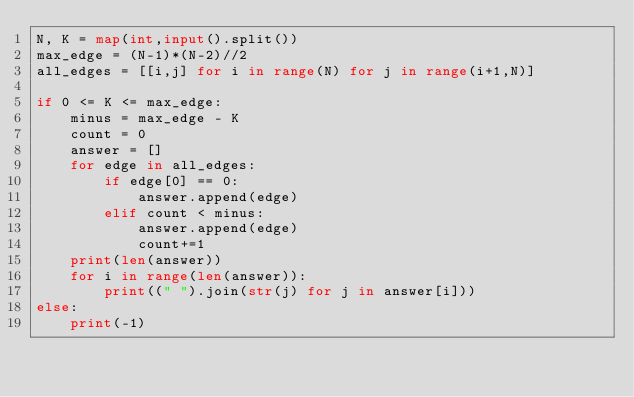<code> <loc_0><loc_0><loc_500><loc_500><_Python_>N, K = map(int,input().split())
max_edge = (N-1)*(N-2)//2
all_edges = [[i,j] for i in range(N) for j in range(i+1,N)]

if 0 <= K <= max_edge:
    minus = max_edge - K
    count = 0
    answer = []
    for edge in all_edges:
        if edge[0] == 0:
            answer.append(edge)
        elif count < minus:
            answer.append(edge)
            count+=1
    print(len(answer))
    for i in range(len(answer)):
        print((" ").join(str(j) for j in answer[i]))
else:
    print(-1)</code> 